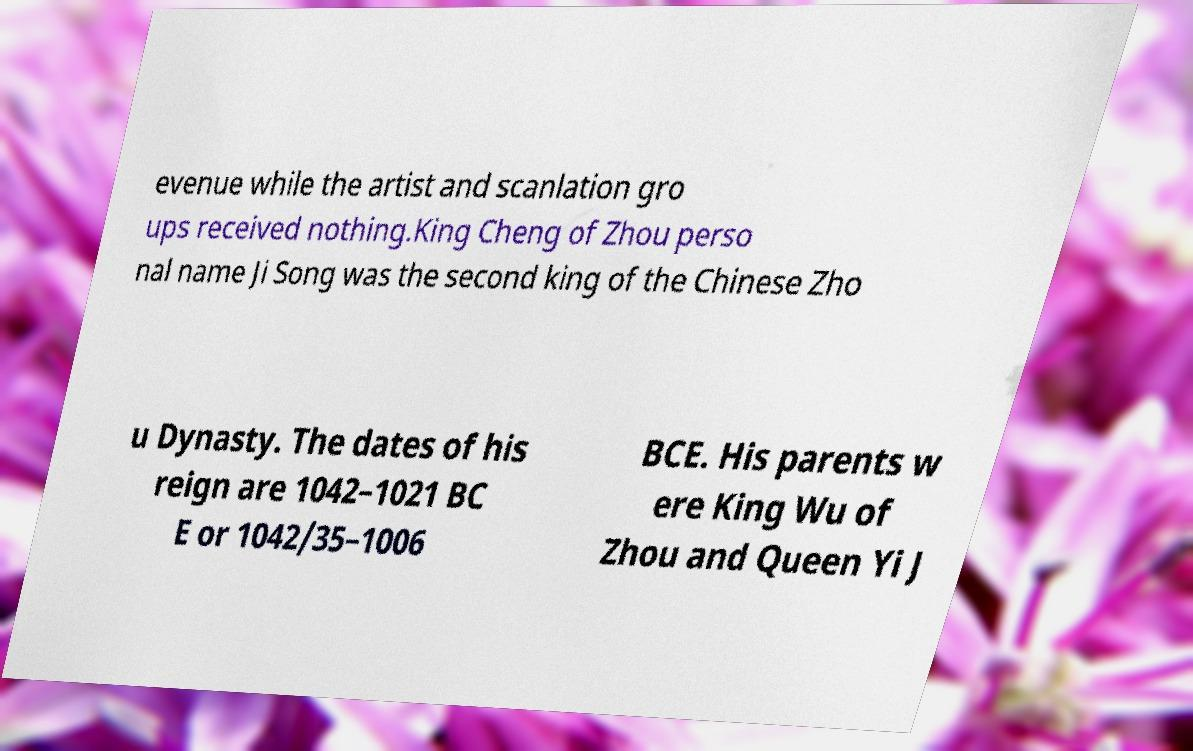For documentation purposes, I need the text within this image transcribed. Could you provide that? evenue while the artist and scanlation gro ups received nothing.King Cheng of Zhou perso nal name Ji Song was the second king of the Chinese Zho u Dynasty. The dates of his reign are 1042–1021 BC E or 1042/35–1006 BCE. His parents w ere King Wu of Zhou and Queen Yi J 